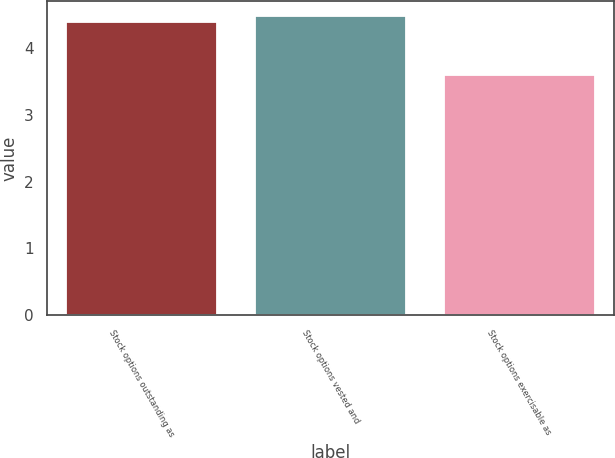Convert chart. <chart><loc_0><loc_0><loc_500><loc_500><bar_chart><fcel>Stock options outstanding as<fcel>Stock options vested and<fcel>Stock options exercisable as<nl><fcel>4.4<fcel>4.48<fcel>3.6<nl></chart> 